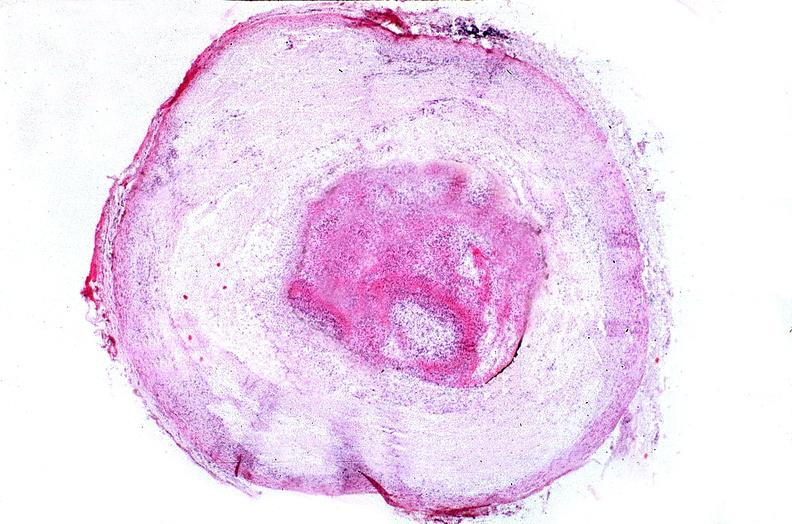where is this from?
Answer the question using a single word or phrase. Vasculature 